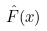Convert formula to latex. <formula><loc_0><loc_0><loc_500><loc_500>\hat { F } ( x )</formula> 